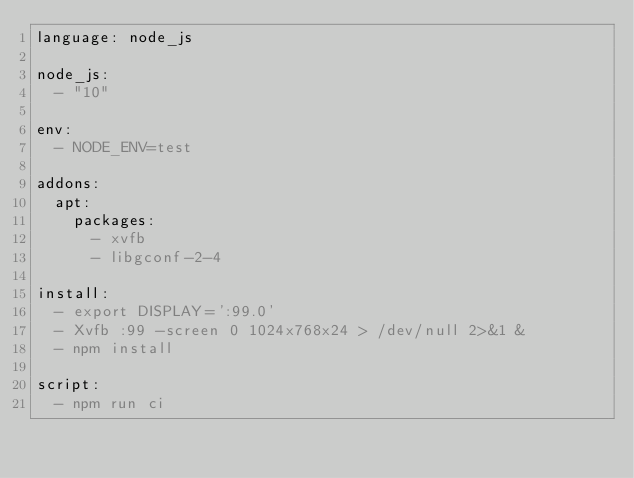Convert code to text. <code><loc_0><loc_0><loc_500><loc_500><_YAML_>language: node_js

node_js:
  - "10"

env:
  - NODE_ENV=test

addons:
  apt:
    packages:
      - xvfb
      - libgconf-2-4

install:
  - export DISPLAY=':99.0'
  - Xvfb :99 -screen 0 1024x768x24 > /dev/null 2>&1 &
  - npm install

script:
  - npm run ci
</code> 